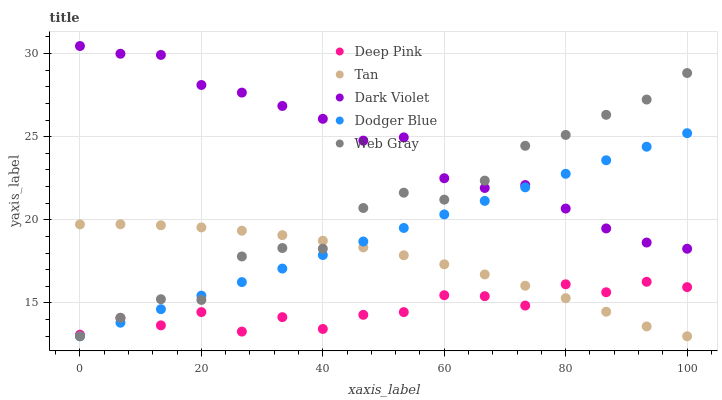Does Deep Pink have the minimum area under the curve?
Answer yes or no. Yes. Does Dark Violet have the maximum area under the curve?
Answer yes or no. Yes. Does Tan have the minimum area under the curve?
Answer yes or no. No. Does Tan have the maximum area under the curve?
Answer yes or no. No. Is Dodger Blue the smoothest?
Answer yes or no. Yes. Is Deep Pink the roughest?
Answer yes or no. Yes. Is Tan the smoothest?
Answer yes or no. No. Is Tan the roughest?
Answer yes or no. No. Does Web Gray have the lowest value?
Answer yes or no. Yes. Does Deep Pink have the lowest value?
Answer yes or no. No. Does Dark Violet have the highest value?
Answer yes or no. Yes. Does Tan have the highest value?
Answer yes or no. No. Is Tan less than Dark Violet?
Answer yes or no. Yes. Is Dark Violet greater than Tan?
Answer yes or no. Yes. Does Dodger Blue intersect Tan?
Answer yes or no. Yes. Is Dodger Blue less than Tan?
Answer yes or no. No. Is Dodger Blue greater than Tan?
Answer yes or no. No. Does Tan intersect Dark Violet?
Answer yes or no. No. 